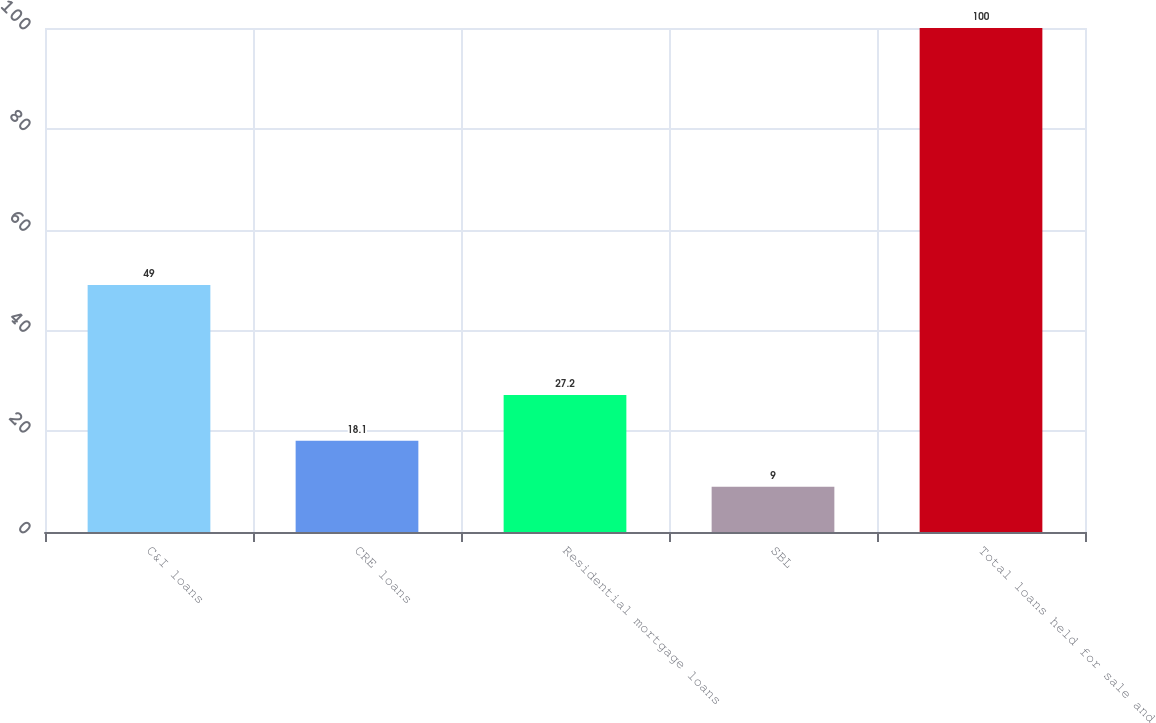Convert chart. <chart><loc_0><loc_0><loc_500><loc_500><bar_chart><fcel>C&I loans<fcel>CRE loans<fcel>Residential mortgage loans<fcel>SBL<fcel>Total loans held for sale and<nl><fcel>49<fcel>18.1<fcel>27.2<fcel>9<fcel>100<nl></chart> 